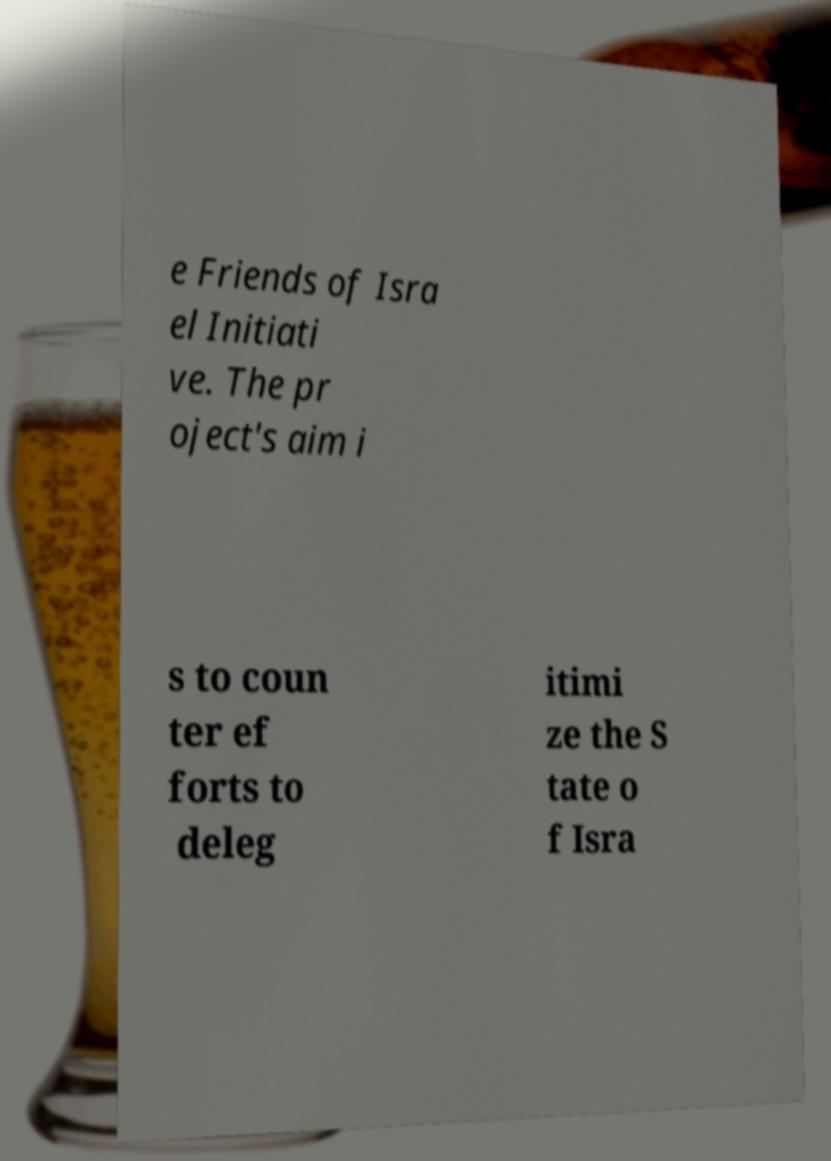Can you accurately transcribe the text from the provided image for me? e Friends of Isra el Initiati ve. The pr oject's aim i s to coun ter ef forts to deleg itimi ze the S tate o f Isra 